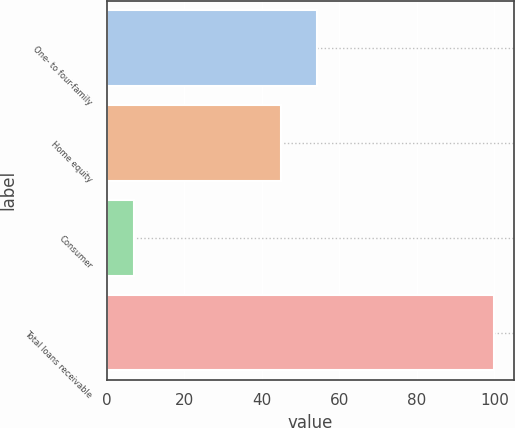Convert chart. <chart><loc_0><loc_0><loc_500><loc_500><bar_chart><fcel>One- to four-family<fcel>Home equity<fcel>Consumer<fcel>Total loans receivable<nl><fcel>54.3<fcel>45<fcel>7<fcel>100<nl></chart> 